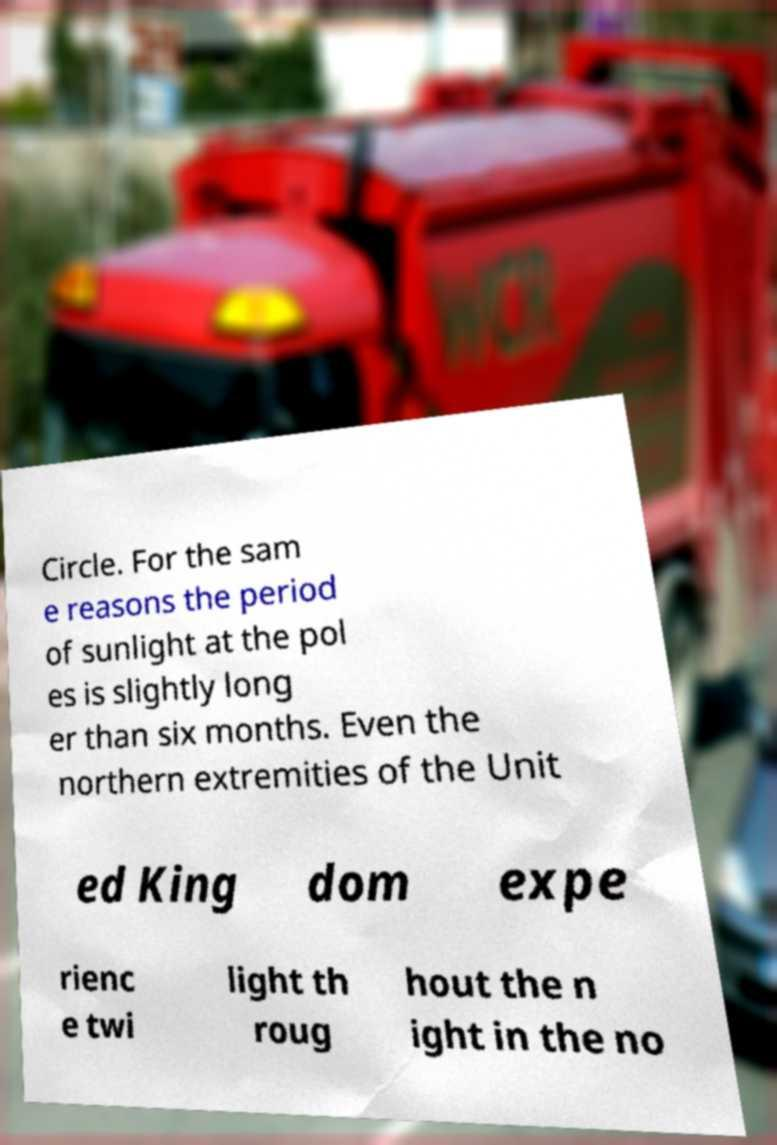Could you assist in decoding the text presented in this image and type it out clearly? Circle. For the sam e reasons the period of sunlight at the pol es is slightly long er than six months. Even the northern extremities of the Unit ed King dom expe rienc e twi light th roug hout the n ight in the no 